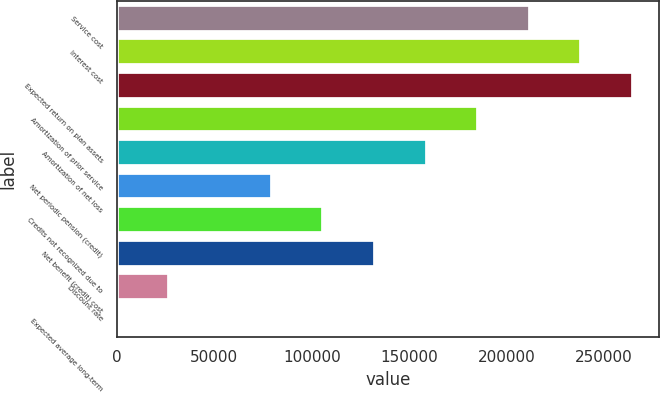<chart> <loc_0><loc_0><loc_500><loc_500><bar_chart><fcel>Service cost<fcel>Interest cost<fcel>Expected return on plan assets<fcel>Amortization of prior service<fcel>Amortization of net loss<fcel>Net periodic pension (credit)<fcel>Credits not recognized due to<fcel>Net benefit (credit) cost<fcel>Discount rate<fcel>Expected average long-term<nl><fcel>211866<fcel>238348<fcel>264831<fcel>185383<fcel>158900<fcel>79452.1<fcel>105935<fcel>132418<fcel>26486.7<fcel>4<nl></chart> 